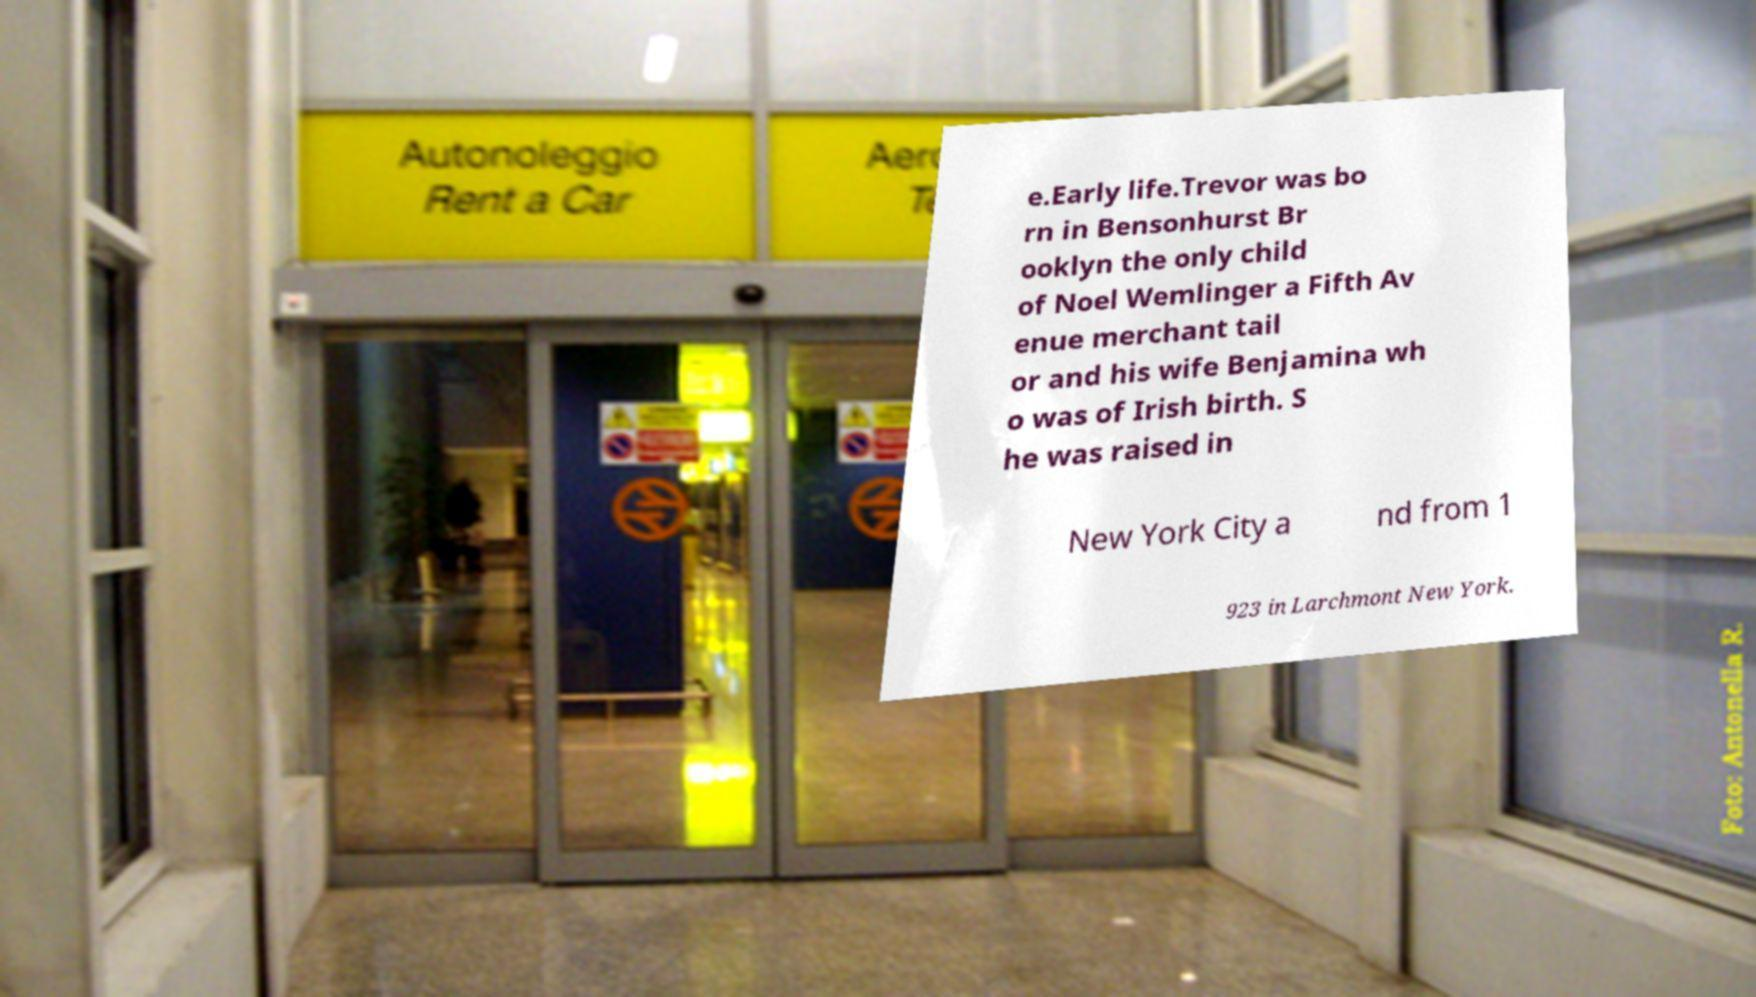Could you extract and type out the text from this image? e.Early life.Trevor was bo rn in Bensonhurst Br ooklyn the only child of Noel Wemlinger a Fifth Av enue merchant tail or and his wife Benjamina wh o was of Irish birth. S he was raised in New York City a nd from 1 923 in Larchmont New York. 